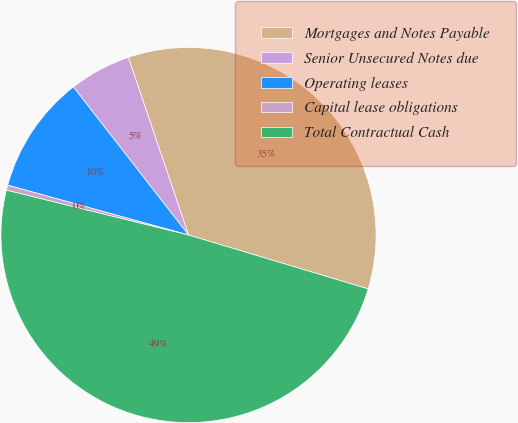Convert chart to OTSL. <chart><loc_0><loc_0><loc_500><loc_500><pie_chart><fcel>Mortgages and Notes Payable<fcel>Senior Unsecured Notes due<fcel>Operating leases<fcel>Capital lease obligations<fcel>Total Contractual Cash<nl><fcel>34.84%<fcel>5.32%<fcel>10.2%<fcel>0.44%<fcel>49.2%<nl></chart> 